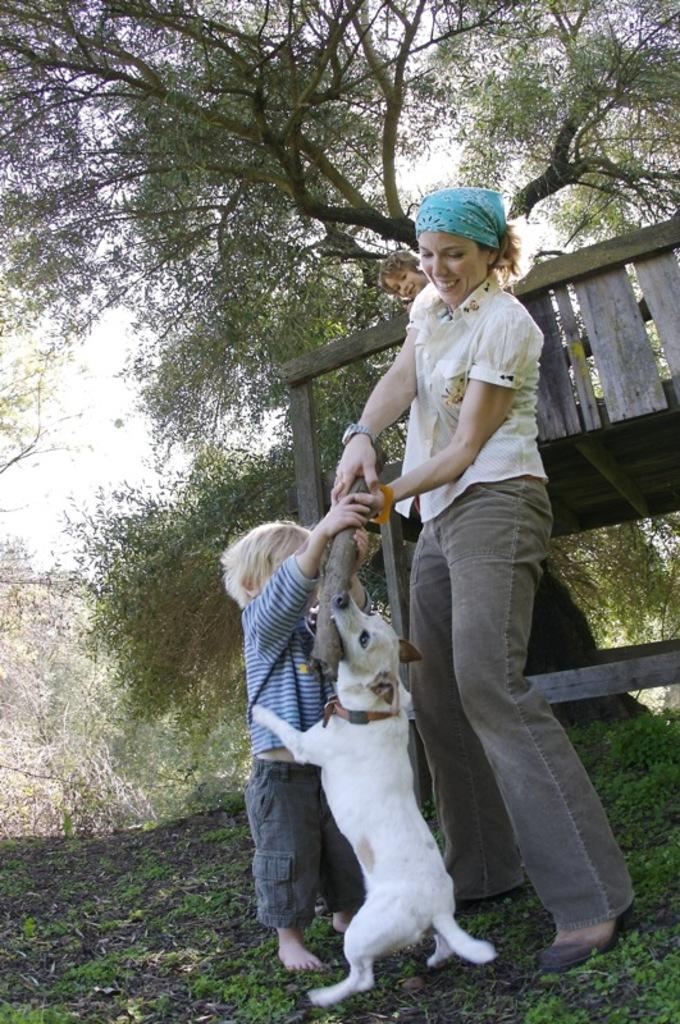Can you describe this image briefly? In this image we can see a woman, kiss, dog. In the background of the image there are trees. At the bottom of the image there is grass. 